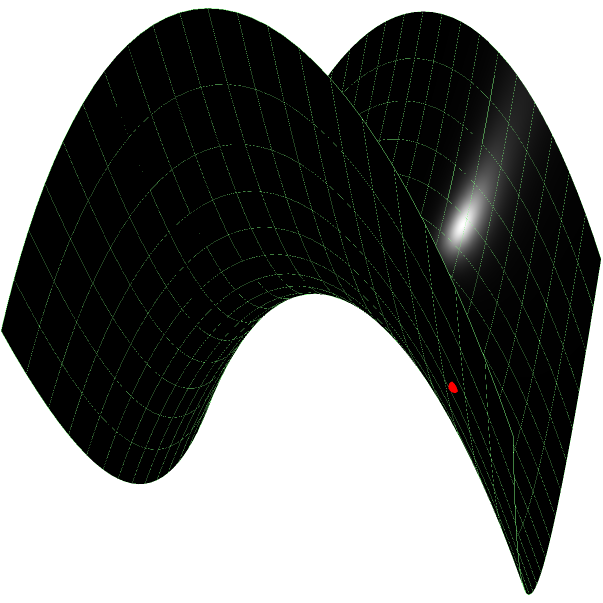Consider a saddle-shaped surface described by the equation $z = x^2 - y^2$. Two points, A(-1.5, -1.5, 0) and B(1.5, 1.5, 0), are marked on this surface. What is the equation of the geodesic (shortest path) connecting these two points on the surface? Express your answer in parametric form where $t \in [0,1]$. To find the geodesic on a saddle-shaped surface, we can follow these steps:

1) First, we recognize that the surface is a hyperbolic paraboloid, which has the unique property that its straight line generators are also geodesics.

2) The equation of the surface is $z = x^2 - y^2$. We can rewrite this as:
   $$(x+y)(x-y) = z$$

3) This form reveals that the surface contains two families of straight lines:
   - $x+y = k_1$ and $x-y = z/k_1$
   - $x-y = k_2$ and $x+y = z/k_2$

4) Our points A(-1.5, -1.5, 0) and B(1.5, 1.5, 0) lie on the line $x = y$, which is one of these straight lines on the surface.

5) Therefore, the geodesic between A and B is simply the straight line connecting them.

6) We can parameterize this line with $t \in [0,1]$ as follows:
   $x(t) = 1.5t - 1.5$
   $y(t) = 1.5t - 1.5$
   $z(t) = (1.5t - 1.5)^2 - (1.5t - 1.5)^2 = 0$

7) Thus, our parametric equation for the geodesic is:
   $$(1.5t - 1.5, 1.5t - 1.5, 0)$$
   where $t \in [0,1]$
Answer: $(1.5t - 1.5, 1.5t - 1.5, 0)$, $t \in [0,1]$ 